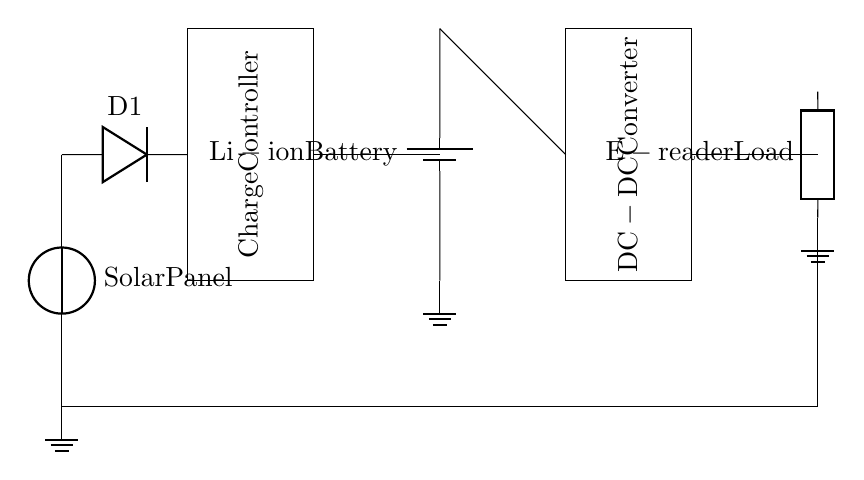What is the main energy source for this circuit? The main energy source is the solar panel, which converts sunlight into electrical energy to charge the battery.
Answer: solar panel What type of battery is used in this circuit? The circuit uses a lithium-ion battery, which is indicated in the diagram as "Li-ion Battery."
Answer: Li-ion Battery Which component regulates the charging process in this circuit? The component that regulates the charging process is the charge controller, which ensures that the battery is charged safely and efficiently.
Answer: Charge Controller How many components are in series before the e-reader load? There are four components in series before the e-reader load: the solar panel, diode, charge controller, and battery. These components are arranged in a linear sequence leading to the load.
Answer: four What is the purpose of the diode in this circuit? The diode's purpose is to prevent reverse current flow, ensuring that the current can only move in one direction—from the solar panel to the battery and load.
Answer: prevent reverse current What is the function of the DC-DC converter in this circuit? The DC-DC converter steps up or steps down the voltage from the battery to match the voltage requirements of the e-reader, allowing it to operate effectively.
Answer: voltage matching What is the function of the load in this circuit? The load in this circuit is the e-reader, which consumes electrical energy to operate and display content for outdoor poetry reading.
Answer: e-reader 